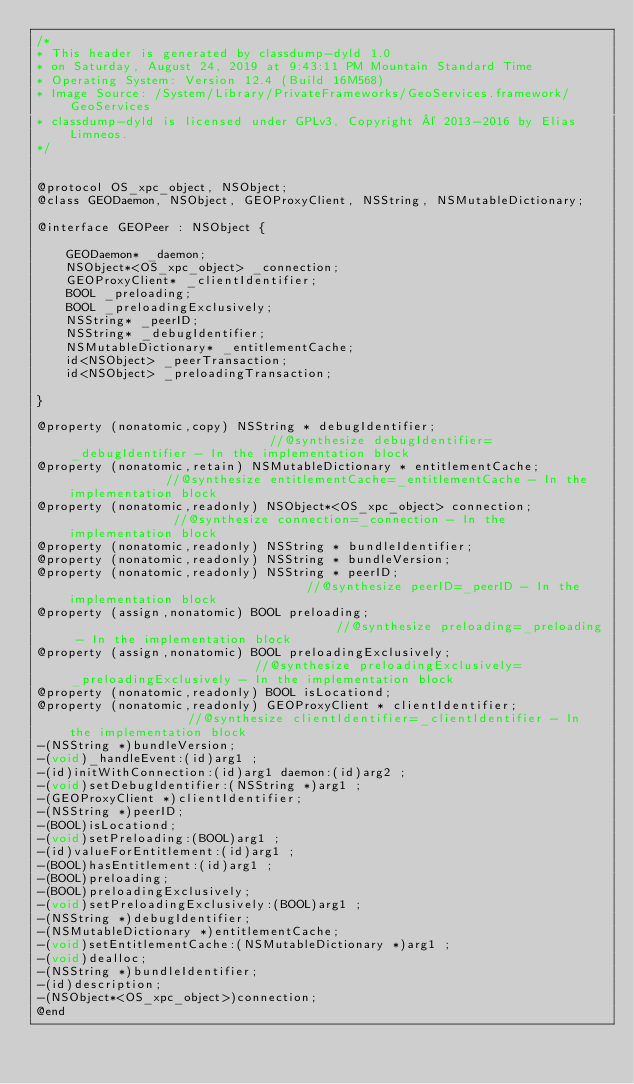Convert code to text. <code><loc_0><loc_0><loc_500><loc_500><_C_>/*
* This header is generated by classdump-dyld 1.0
* on Saturday, August 24, 2019 at 9:43:11 PM Mountain Standard Time
* Operating System: Version 12.4 (Build 16M568)
* Image Source: /System/Library/PrivateFrameworks/GeoServices.framework/GeoServices
* classdump-dyld is licensed under GPLv3, Copyright © 2013-2016 by Elias Limneos.
*/


@protocol OS_xpc_object, NSObject;
@class GEODaemon, NSObject, GEOProxyClient, NSString, NSMutableDictionary;

@interface GEOPeer : NSObject {

	GEODaemon* _daemon;
	NSObject*<OS_xpc_object> _connection;
	GEOProxyClient* _clientIdentifier;
	BOOL _preloading;
	BOOL _preloadingExclusively;
	NSString* _peerID;
	NSString* _debugIdentifier;
	NSMutableDictionary* _entitlementCache;
	id<NSObject> _peerTransaction;
	id<NSObject> _preloadingTransaction;

}

@property (nonatomic,copy) NSString * debugIdentifier;                            //@synthesize debugIdentifier=_debugIdentifier - In the implementation block
@property (nonatomic,retain) NSMutableDictionary * entitlementCache;              //@synthesize entitlementCache=_entitlementCache - In the implementation block
@property (nonatomic,readonly) NSObject*<OS_xpc_object> connection;               //@synthesize connection=_connection - In the implementation block
@property (nonatomic,readonly) NSString * bundleIdentifier; 
@property (nonatomic,readonly) NSString * bundleVersion; 
@property (nonatomic,readonly) NSString * peerID;                                 //@synthesize peerID=_peerID - In the implementation block
@property (assign,nonatomic) BOOL preloading;                                     //@synthesize preloading=_preloading - In the implementation block
@property (assign,nonatomic) BOOL preloadingExclusively;                          //@synthesize preloadingExclusively=_preloadingExclusively - In the implementation block
@property (nonatomic,readonly) BOOL isLocationd; 
@property (nonatomic,readonly) GEOProxyClient * clientIdentifier;                 //@synthesize clientIdentifier=_clientIdentifier - In the implementation block
-(NSString *)bundleVersion;
-(void)_handleEvent:(id)arg1 ;
-(id)initWithConnection:(id)arg1 daemon:(id)arg2 ;
-(void)setDebugIdentifier:(NSString *)arg1 ;
-(GEOProxyClient *)clientIdentifier;
-(NSString *)peerID;
-(BOOL)isLocationd;
-(void)setPreloading:(BOOL)arg1 ;
-(id)valueForEntitlement:(id)arg1 ;
-(BOOL)hasEntitlement:(id)arg1 ;
-(BOOL)preloading;
-(BOOL)preloadingExclusively;
-(void)setPreloadingExclusively:(BOOL)arg1 ;
-(NSString *)debugIdentifier;
-(NSMutableDictionary *)entitlementCache;
-(void)setEntitlementCache:(NSMutableDictionary *)arg1 ;
-(void)dealloc;
-(NSString *)bundleIdentifier;
-(id)description;
-(NSObject*<OS_xpc_object>)connection;
@end

</code> 